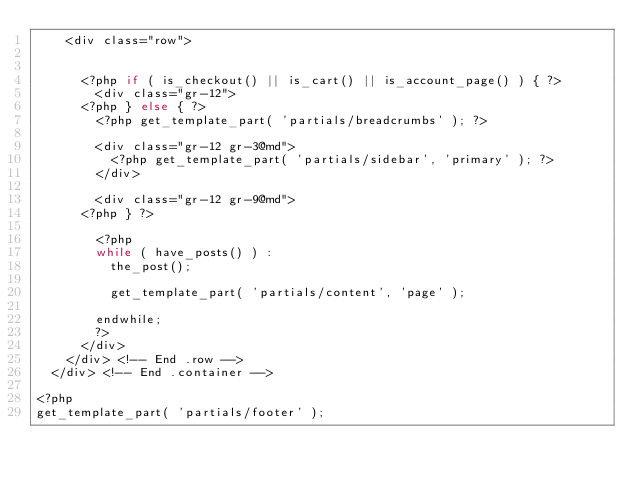Convert code to text. <code><loc_0><loc_0><loc_500><loc_500><_PHP_>		<div class="row">


			<?php if ( is_checkout() || is_cart() || is_account_page() ) { ?>
				<div class="gr-12">
			<?php } else { ?>
				<?php get_template_part( 'partials/breadcrumbs' ); ?>

				<div class="gr-12 gr-3@md">
					<?php get_template_part( 'partials/sidebar', 'primary' ); ?>
				</div>

				<div class="gr-12 gr-9@md">
			<?php } ?>

				<?php
				while ( have_posts() ) :
					the_post();

					get_template_part( 'partials/content', 'page' );

				endwhile;
				?>
			</div>
		</div> <!-- End .row -->
	</div> <!-- End .container -->

<?php
get_template_part( 'partials/footer' );
</code> 